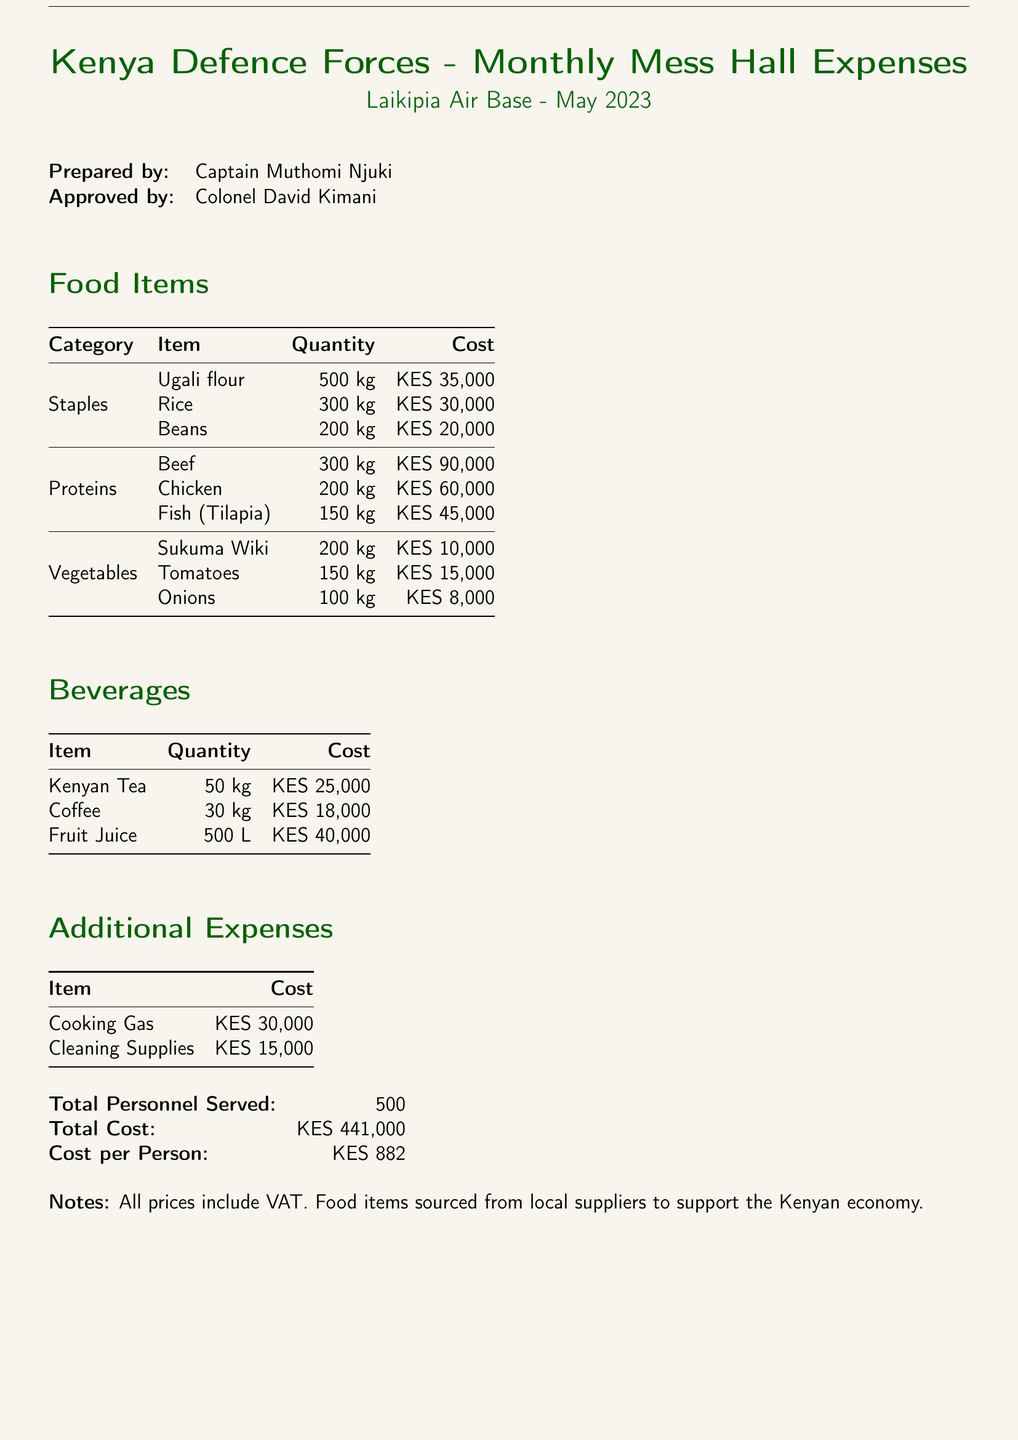what is the total cost of food items? The total cost of food items can be calculated from the food section totals: KES 35,000 + KES 30,000 + KES 20,000 + KES 90,000 + KES 60,000 + KES 45,000 + KES 10,000 + KES 15,000 + KES 8,000 = KES 308,000.
Answer: KES 308,000 how many kilograms of fish were purchased? The document states that 150 kg of fish (Tilapia) were purchased.
Answer: 150 kg who prepared the bill? The document lists Captain Muthomi Njuki as the preparer of the bill.
Answer: Captain Muthomi Njuki what is the cost per person? The cost per person is calculated as the total cost divided by the total personnel served: KES 441,000 divided by 500 equals KES 882.
Answer: KES 882 what was the cost of cooking gas? The document specifies that cooking gas cost KES 30,000.
Answer: KES 30,000 what is the total quantity of vegetables bought? The document lists the quantities of vegetables as 200 kg (Sukuma Wiki) + 150 kg (Tomatoes) + 100 kg (Onions) totaling 450 kg.
Answer: 450 kg what is the quantity of Kenyan tea purchased? The quantity of Kenyan Tea purchased is stated as 50 kg.
Answer: 50 kg who approved the bill? The document indicates that Colonel David Kimani approved the bill.
Answer: Colonel David Kimani what is the total number of personnel served? According to the document, the total number of personnel served is stated as 500.
Answer: 500 